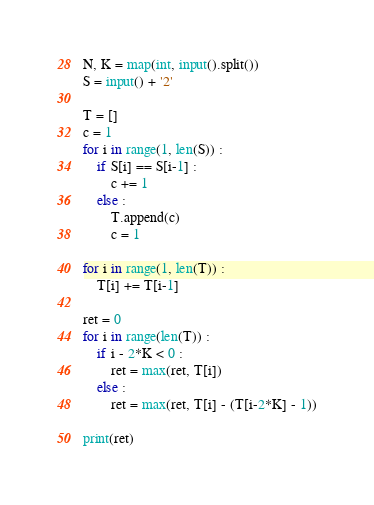Convert code to text. <code><loc_0><loc_0><loc_500><loc_500><_Python_>N, K = map(int, input().split())
S = input() + '2'

T = []
c = 1
for i in range(1, len(S)) :
    if S[i] == S[i-1] :
        c += 1
    else :
        T.append(c)
        c = 1
        
for i in range(1, len(T)) :
    T[i] += T[i-1]

ret = 0
for i in range(len(T)) :
    if i - 2*K < 0 :
        ret = max(ret, T[i])
    else :
        ret = max(ret, T[i] - (T[i-2*K] - 1))
    
print(ret)</code> 